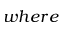Convert formula to latex. <formula><loc_0><loc_0><loc_500><loc_500>w h e r e</formula> 